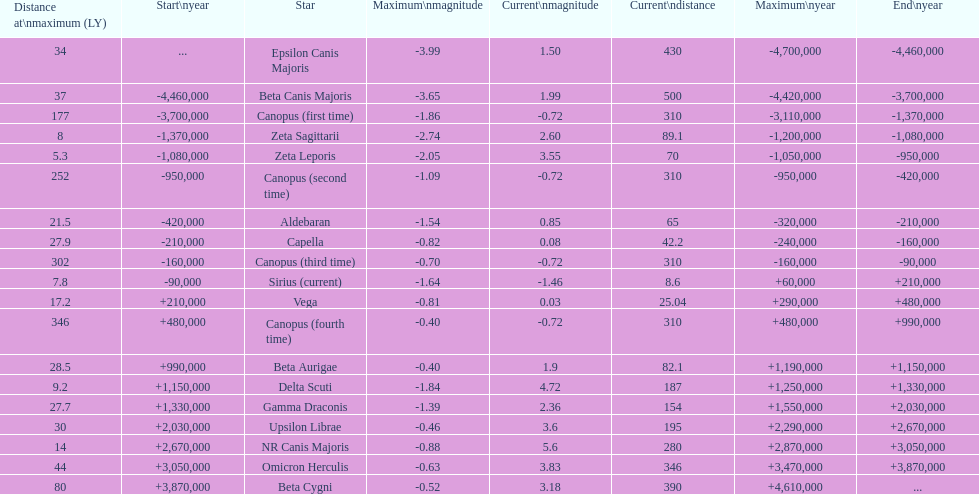Give me the full table as a dictionary. {'header': ['Distance at\\nmaximum (LY)', 'Start\\nyear', 'Star', 'Maximum\\nmagnitude', 'Current\\nmagnitude', 'Current\\ndistance', 'Maximum\\nyear', 'End\\nyear'], 'rows': [['34', '...', 'Epsilon Canis Majoris', '-3.99', '1.50', '430', '-4,700,000', '-4,460,000'], ['37', '-4,460,000', 'Beta Canis Majoris', '-3.65', '1.99', '500', '-4,420,000', '-3,700,000'], ['177', '-3,700,000', 'Canopus (first time)', '-1.86', '-0.72', '310', '-3,110,000', '-1,370,000'], ['8', '-1,370,000', 'Zeta Sagittarii', '-2.74', '2.60', '89.1', '-1,200,000', '-1,080,000'], ['5.3', '-1,080,000', 'Zeta Leporis', '-2.05', '3.55', '70', '-1,050,000', '-950,000'], ['252', '-950,000', 'Canopus (second time)', '-1.09', '-0.72', '310', '-950,000', '-420,000'], ['21.5', '-420,000', 'Aldebaran', '-1.54', '0.85', '65', '-320,000', '-210,000'], ['27.9', '-210,000', 'Capella', '-0.82', '0.08', '42.2', '-240,000', '-160,000'], ['302', '-160,000', 'Canopus (third time)', '-0.70', '-0.72', '310', '-160,000', '-90,000'], ['7.8', '-90,000', 'Sirius (current)', '-1.64', '-1.46', '8.6', '+60,000', '+210,000'], ['17.2', '+210,000', 'Vega', '-0.81', '0.03', '25.04', '+290,000', '+480,000'], ['346', '+480,000', 'Canopus (fourth time)', '-0.40', '-0.72', '310', '+480,000', '+990,000'], ['28.5', '+990,000', 'Beta Aurigae', '-0.40', '1.9', '82.1', '+1,190,000', '+1,150,000'], ['9.2', '+1,150,000', 'Delta Scuti', '-1.84', '4.72', '187', '+1,250,000', '+1,330,000'], ['27.7', '+1,330,000', 'Gamma Draconis', '-1.39', '2.36', '154', '+1,550,000', '+2,030,000'], ['30', '+2,030,000', 'Upsilon Librae', '-0.46', '3.6', '195', '+2,290,000', '+2,670,000'], ['14', '+2,670,000', 'NR Canis Majoris', '-0.88', '5.6', '280', '+2,870,000', '+3,050,000'], ['44', '+3,050,000', 'Omicron Herculis', '-0.63', '3.83', '346', '+3,470,000', '+3,870,000'], ['80', '+3,870,000', 'Beta Cygni', '-0.52', '3.18', '390', '+4,610,000', '...']]} How many stars have a magnitude greater than zero? 14. 